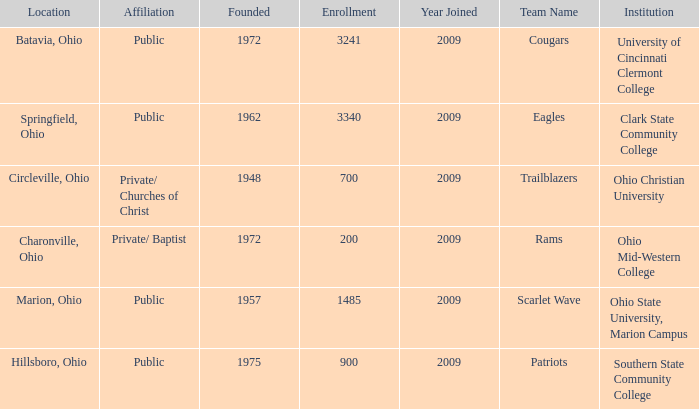What is the location for the team name of eagles? Springfield, Ohio. 